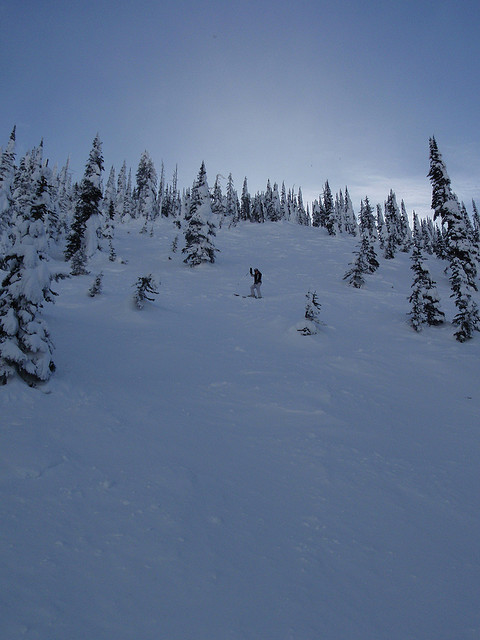<image>Which direction is the sun in the photo? It is unknown which direction the sun is in the photo. Which direction is the sun in the photo? I am not sure which direction the sun is in the photo. 